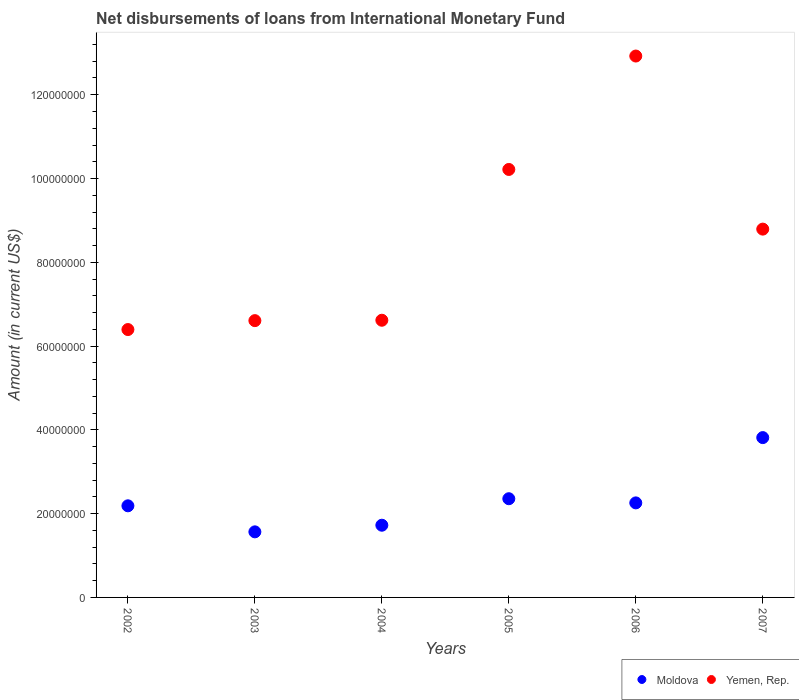How many different coloured dotlines are there?
Ensure brevity in your answer.  2. What is the amount of loans disbursed in Yemen, Rep. in 2004?
Your response must be concise. 6.62e+07. Across all years, what is the maximum amount of loans disbursed in Yemen, Rep.?
Your response must be concise. 1.29e+08. Across all years, what is the minimum amount of loans disbursed in Moldova?
Ensure brevity in your answer.  1.57e+07. In which year was the amount of loans disbursed in Moldova maximum?
Make the answer very short. 2007. What is the total amount of loans disbursed in Moldova in the graph?
Your response must be concise. 1.39e+08. What is the difference between the amount of loans disbursed in Yemen, Rep. in 2004 and that in 2005?
Your answer should be very brief. -3.60e+07. What is the difference between the amount of loans disbursed in Moldova in 2002 and the amount of loans disbursed in Yemen, Rep. in 2005?
Provide a short and direct response. -8.03e+07. What is the average amount of loans disbursed in Moldova per year?
Give a very brief answer. 2.32e+07. In the year 2003, what is the difference between the amount of loans disbursed in Yemen, Rep. and amount of loans disbursed in Moldova?
Offer a very short reply. 5.04e+07. In how many years, is the amount of loans disbursed in Moldova greater than 104000000 US$?
Ensure brevity in your answer.  0. What is the ratio of the amount of loans disbursed in Yemen, Rep. in 2005 to that in 2007?
Keep it short and to the point. 1.16. Is the amount of loans disbursed in Yemen, Rep. in 2004 less than that in 2007?
Your response must be concise. Yes. What is the difference between the highest and the second highest amount of loans disbursed in Moldova?
Ensure brevity in your answer.  1.46e+07. What is the difference between the highest and the lowest amount of loans disbursed in Moldova?
Keep it short and to the point. 2.25e+07. In how many years, is the amount of loans disbursed in Moldova greater than the average amount of loans disbursed in Moldova taken over all years?
Offer a terse response. 2. Does the amount of loans disbursed in Yemen, Rep. monotonically increase over the years?
Keep it short and to the point. No. Is the amount of loans disbursed in Moldova strictly greater than the amount of loans disbursed in Yemen, Rep. over the years?
Ensure brevity in your answer.  No. How many dotlines are there?
Keep it short and to the point. 2. What is the difference between two consecutive major ticks on the Y-axis?
Provide a succinct answer. 2.00e+07. Are the values on the major ticks of Y-axis written in scientific E-notation?
Your answer should be compact. No. Does the graph contain any zero values?
Keep it short and to the point. No. Where does the legend appear in the graph?
Keep it short and to the point. Bottom right. How many legend labels are there?
Your response must be concise. 2. How are the legend labels stacked?
Offer a very short reply. Horizontal. What is the title of the graph?
Make the answer very short. Net disbursements of loans from International Monetary Fund. What is the label or title of the X-axis?
Offer a very short reply. Years. What is the Amount (in current US$) of Moldova in 2002?
Your response must be concise. 2.19e+07. What is the Amount (in current US$) in Yemen, Rep. in 2002?
Keep it short and to the point. 6.39e+07. What is the Amount (in current US$) of Moldova in 2003?
Provide a succinct answer. 1.57e+07. What is the Amount (in current US$) of Yemen, Rep. in 2003?
Your response must be concise. 6.61e+07. What is the Amount (in current US$) in Moldova in 2004?
Your response must be concise. 1.72e+07. What is the Amount (in current US$) in Yemen, Rep. in 2004?
Your answer should be compact. 6.62e+07. What is the Amount (in current US$) of Moldova in 2005?
Provide a succinct answer. 2.36e+07. What is the Amount (in current US$) of Yemen, Rep. in 2005?
Provide a succinct answer. 1.02e+08. What is the Amount (in current US$) of Moldova in 2006?
Make the answer very short. 2.26e+07. What is the Amount (in current US$) in Yemen, Rep. in 2006?
Your answer should be very brief. 1.29e+08. What is the Amount (in current US$) of Moldova in 2007?
Make the answer very short. 3.82e+07. What is the Amount (in current US$) in Yemen, Rep. in 2007?
Ensure brevity in your answer.  8.79e+07. Across all years, what is the maximum Amount (in current US$) in Moldova?
Provide a succinct answer. 3.82e+07. Across all years, what is the maximum Amount (in current US$) in Yemen, Rep.?
Provide a short and direct response. 1.29e+08. Across all years, what is the minimum Amount (in current US$) in Moldova?
Make the answer very short. 1.57e+07. Across all years, what is the minimum Amount (in current US$) of Yemen, Rep.?
Your answer should be very brief. 6.39e+07. What is the total Amount (in current US$) in Moldova in the graph?
Provide a succinct answer. 1.39e+08. What is the total Amount (in current US$) in Yemen, Rep. in the graph?
Offer a terse response. 5.16e+08. What is the difference between the Amount (in current US$) in Moldova in 2002 and that in 2003?
Provide a succinct answer. 6.22e+06. What is the difference between the Amount (in current US$) of Yemen, Rep. in 2002 and that in 2003?
Provide a succinct answer. -2.13e+06. What is the difference between the Amount (in current US$) in Moldova in 2002 and that in 2004?
Your answer should be very brief. 4.63e+06. What is the difference between the Amount (in current US$) of Yemen, Rep. in 2002 and that in 2004?
Your answer should be very brief. -2.22e+06. What is the difference between the Amount (in current US$) in Moldova in 2002 and that in 2005?
Ensure brevity in your answer.  -1.69e+06. What is the difference between the Amount (in current US$) in Yemen, Rep. in 2002 and that in 2005?
Keep it short and to the point. -3.82e+07. What is the difference between the Amount (in current US$) of Moldova in 2002 and that in 2006?
Offer a terse response. -6.98e+05. What is the difference between the Amount (in current US$) of Yemen, Rep. in 2002 and that in 2006?
Keep it short and to the point. -6.53e+07. What is the difference between the Amount (in current US$) of Moldova in 2002 and that in 2007?
Keep it short and to the point. -1.63e+07. What is the difference between the Amount (in current US$) of Yemen, Rep. in 2002 and that in 2007?
Provide a succinct answer. -2.40e+07. What is the difference between the Amount (in current US$) of Moldova in 2003 and that in 2004?
Your answer should be compact. -1.58e+06. What is the difference between the Amount (in current US$) of Yemen, Rep. in 2003 and that in 2004?
Your answer should be very brief. -9.40e+04. What is the difference between the Amount (in current US$) of Moldova in 2003 and that in 2005?
Make the answer very short. -7.91e+06. What is the difference between the Amount (in current US$) of Yemen, Rep. in 2003 and that in 2005?
Make the answer very short. -3.61e+07. What is the difference between the Amount (in current US$) in Moldova in 2003 and that in 2006?
Your answer should be compact. -6.91e+06. What is the difference between the Amount (in current US$) of Yemen, Rep. in 2003 and that in 2006?
Offer a terse response. -6.32e+07. What is the difference between the Amount (in current US$) in Moldova in 2003 and that in 2007?
Provide a succinct answer. -2.25e+07. What is the difference between the Amount (in current US$) of Yemen, Rep. in 2003 and that in 2007?
Ensure brevity in your answer.  -2.18e+07. What is the difference between the Amount (in current US$) in Moldova in 2004 and that in 2005?
Offer a very short reply. -6.33e+06. What is the difference between the Amount (in current US$) of Yemen, Rep. in 2004 and that in 2005?
Provide a succinct answer. -3.60e+07. What is the difference between the Amount (in current US$) in Moldova in 2004 and that in 2006?
Ensure brevity in your answer.  -5.33e+06. What is the difference between the Amount (in current US$) of Yemen, Rep. in 2004 and that in 2006?
Keep it short and to the point. -6.31e+07. What is the difference between the Amount (in current US$) of Moldova in 2004 and that in 2007?
Make the answer very short. -2.09e+07. What is the difference between the Amount (in current US$) in Yemen, Rep. in 2004 and that in 2007?
Ensure brevity in your answer.  -2.18e+07. What is the difference between the Amount (in current US$) in Moldova in 2005 and that in 2006?
Offer a terse response. 9.95e+05. What is the difference between the Amount (in current US$) of Yemen, Rep. in 2005 and that in 2006?
Provide a succinct answer. -2.71e+07. What is the difference between the Amount (in current US$) in Moldova in 2005 and that in 2007?
Ensure brevity in your answer.  -1.46e+07. What is the difference between the Amount (in current US$) in Yemen, Rep. in 2005 and that in 2007?
Provide a succinct answer. 1.42e+07. What is the difference between the Amount (in current US$) in Moldova in 2006 and that in 2007?
Your response must be concise. -1.56e+07. What is the difference between the Amount (in current US$) of Yemen, Rep. in 2006 and that in 2007?
Offer a terse response. 4.13e+07. What is the difference between the Amount (in current US$) in Moldova in 2002 and the Amount (in current US$) in Yemen, Rep. in 2003?
Keep it short and to the point. -4.42e+07. What is the difference between the Amount (in current US$) in Moldova in 2002 and the Amount (in current US$) in Yemen, Rep. in 2004?
Offer a very short reply. -4.43e+07. What is the difference between the Amount (in current US$) in Moldova in 2002 and the Amount (in current US$) in Yemen, Rep. in 2005?
Provide a short and direct response. -8.03e+07. What is the difference between the Amount (in current US$) in Moldova in 2002 and the Amount (in current US$) in Yemen, Rep. in 2006?
Your answer should be compact. -1.07e+08. What is the difference between the Amount (in current US$) in Moldova in 2002 and the Amount (in current US$) in Yemen, Rep. in 2007?
Give a very brief answer. -6.61e+07. What is the difference between the Amount (in current US$) in Moldova in 2003 and the Amount (in current US$) in Yemen, Rep. in 2004?
Provide a short and direct response. -5.05e+07. What is the difference between the Amount (in current US$) of Moldova in 2003 and the Amount (in current US$) of Yemen, Rep. in 2005?
Make the answer very short. -8.65e+07. What is the difference between the Amount (in current US$) of Moldova in 2003 and the Amount (in current US$) of Yemen, Rep. in 2006?
Your answer should be compact. -1.14e+08. What is the difference between the Amount (in current US$) in Moldova in 2003 and the Amount (in current US$) in Yemen, Rep. in 2007?
Provide a short and direct response. -7.23e+07. What is the difference between the Amount (in current US$) of Moldova in 2004 and the Amount (in current US$) of Yemen, Rep. in 2005?
Keep it short and to the point. -8.49e+07. What is the difference between the Amount (in current US$) of Moldova in 2004 and the Amount (in current US$) of Yemen, Rep. in 2006?
Ensure brevity in your answer.  -1.12e+08. What is the difference between the Amount (in current US$) of Moldova in 2004 and the Amount (in current US$) of Yemen, Rep. in 2007?
Your answer should be compact. -7.07e+07. What is the difference between the Amount (in current US$) of Moldova in 2005 and the Amount (in current US$) of Yemen, Rep. in 2006?
Keep it short and to the point. -1.06e+08. What is the difference between the Amount (in current US$) of Moldova in 2005 and the Amount (in current US$) of Yemen, Rep. in 2007?
Your response must be concise. -6.44e+07. What is the difference between the Amount (in current US$) in Moldova in 2006 and the Amount (in current US$) in Yemen, Rep. in 2007?
Give a very brief answer. -6.54e+07. What is the average Amount (in current US$) in Moldova per year?
Your answer should be compact. 2.32e+07. What is the average Amount (in current US$) of Yemen, Rep. per year?
Your response must be concise. 8.59e+07. In the year 2002, what is the difference between the Amount (in current US$) in Moldova and Amount (in current US$) in Yemen, Rep.?
Provide a succinct answer. -4.21e+07. In the year 2003, what is the difference between the Amount (in current US$) of Moldova and Amount (in current US$) of Yemen, Rep.?
Ensure brevity in your answer.  -5.04e+07. In the year 2004, what is the difference between the Amount (in current US$) in Moldova and Amount (in current US$) in Yemen, Rep.?
Your answer should be very brief. -4.89e+07. In the year 2005, what is the difference between the Amount (in current US$) of Moldova and Amount (in current US$) of Yemen, Rep.?
Your answer should be very brief. -7.86e+07. In the year 2006, what is the difference between the Amount (in current US$) of Moldova and Amount (in current US$) of Yemen, Rep.?
Provide a succinct answer. -1.07e+08. In the year 2007, what is the difference between the Amount (in current US$) in Moldova and Amount (in current US$) in Yemen, Rep.?
Make the answer very short. -4.98e+07. What is the ratio of the Amount (in current US$) in Moldova in 2002 to that in 2003?
Your answer should be compact. 1.4. What is the ratio of the Amount (in current US$) of Yemen, Rep. in 2002 to that in 2003?
Give a very brief answer. 0.97. What is the ratio of the Amount (in current US$) of Moldova in 2002 to that in 2004?
Give a very brief answer. 1.27. What is the ratio of the Amount (in current US$) in Yemen, Rep. in 2002 to that in 2004?
Your answer should be compact. 0.97. What is the ratio of the Amount (in current US$) in Moldova in 2002 to that in 2005?
Ensure brevity in your answer.  0.93. What is the ratio of the Amount (in current US$) in Yemen, Rep. in 2002 to that in 2005?
Give a very brief answer. 0.63. What is the ratio of the Amount (in current US$) of Moldova in 2002 to that in 2006?
Your answer should be compact. 0.97. What is the ratio of the Amount (in current US$) of Yemen, Rep. in 2002 to that in 2006?
Keep it short and to the point. 0.49. What is the ratio of the Amount (in current US$) of Moldova in 2002 to that in 2007?
Provide a succinct answer. 0.57. What is the ratio of the Amount (in current US$) in Yemen, Rep. in 2002 to that in 2007?
Your answer should be very brief. 0.73. What is the ratio of the Amount (in current US$) of Moldova in 2003 to that in 2004?
Provide a succinct answer. 0.91. What is the ratio of the Amount (in current US$) in Yemen, Rep. in 2003 to that in 2004?
Give a very brief answer. 1. What is the ratio of the Amount (in current US$) of Moldova in 2003 to that in 2005?
Ensure brevity in your answer.  0.66. What is the ratio of the Amount (in current US$) in Yemen, Rep. in 2003 to that in 2005?
Your answer should be compact. 0.65. What is the ratio of the Amount (in current US$) of Moldova in 2003 to that in 2006?
Give a very brief answer. 0.69. What is the ratio of the Amount (in current US$) in Yemen, Rep. in 2003 to that in 2006?
Ensure brevity in your answer.  0.51. What is the ratio of the Amount (in current US$) in Moldova in 2003 to that in 2007?
Keep it short and to the point. 0.41. What is the ratio of the Amount (in current US$) of Yemen, Rep. in 2003 to that in 2007?
Your response must be concise. 0.75. What is the ratio of the Amount (in current US$) of Moldova in 2004 to that in 2005?
Your response must be concise. 0.73. What is the ratio of the Amount (in current US$) in Yemen, Rep. in 2004 to that in 2005?
Offer a terse response. 0.65. What is the ratio of the Amount (in current US$) of Moldova in 2004 to that in 2006?
Provide a succinct answer. 0.76. What is the ratio of the Amount (in current US$) in Yemen, Rep. in 2004 to that in 2006?
Your answer should be compact. 0.51. What is the ratio of the Amount (in current US$) in Moldova in 2004 to that in 2007?
Give a very brief answer. 0.45. What is the ratio of the Amount (in current US$) in Yemen, Rep. in 2004 to that in 2007?
Give a very brief answer. 0.75. What is the ratio of the Amount (in current US$) of Moldova in 2005 to that in 2006?
Your response must be concise. 1.04. What is the ratio of the Amount (in current US$) in Yemen, Rep. in 2005 to that in 2006?
Keep it short and to the point. 0.79. What is the ratio of the Amount (in current US$) in Moldova in 2005 to that in 2007?
Offer a terse response. 0.62. What is the ratio of the Amount (in current US$) of Yemen, Rep. in 2005 to that in 2007?
Your answer should be very brief. 1.16. What is the ratio of the Amount (in current US$) of Moldova in 2006 to that in 2007?
Your answer should be compact. 0.59. What is the ratio of the Amount (in current US$) in Yemen, Rep. in 2006 to that in 2007?
Offer a terse response. 1.47. What is the difference between the highest and the second highest Amount (in current US$) of Moldova?
Your answer should be compact. 1.46e+07. What is the difference between the highest and the second highest Amount (in current US$) of Yemen, Rep.?
Your answer should be very brief. 2.71e+07. What is the difference between the highest and the lowest Amount (in current US$) in Moldova?
Offer a terse response. 2.25e+07. What is the difference between the highest and the lowest Amount (in current US$) in Yemen, Rep.?
Make the answer very short. 6.53e+07. 